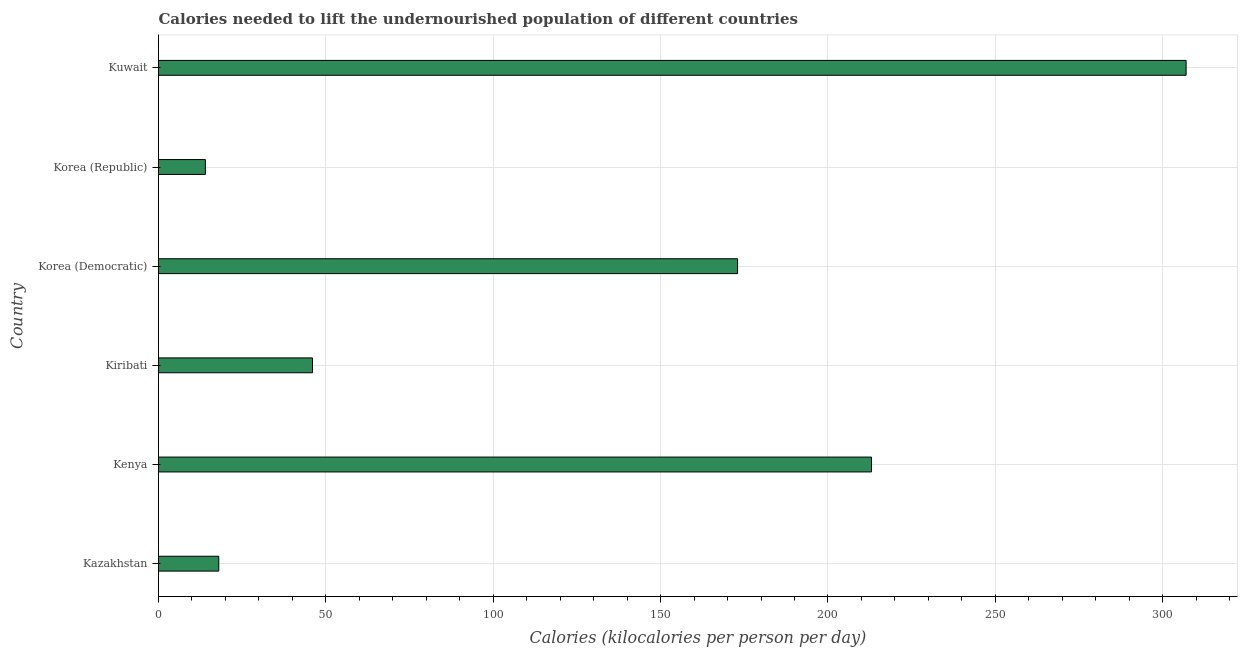Does the graph contain grids?
Your response must be concise. Yes. What is the title of the graph?
Give a very brief answer. Calories needed to lift the undernourished population of different countries. What is the label or title of the X-axis?
Your response must be concise. Calories (kilocalories per person per day). What is the depth of food deficit in Kenya?
Your answer should be compact. 213. Across all countries, what is the maximum depth of food deficit?
Your response must be concise. 307. Across all countries, what is the minimum depth of food deficit?
Provide a short and direct response. 14. In which country was the depth of food deficit maximum?
Offer a very short reply. Kuwait. In which country was the depth of food deficit minimum?
Offer a very short reply. Korea (Republic). What is the sum of the depth of food deficit?
Provide a short and direct response. 771. What is the difference between the depth of food deficit in Kenya and Kiribati?
Provide a succinct answer. 167. What is the average depth of food deficit per country?
Ensure brevity in your answer.  128.5. What is the median depth of food deficit?
Your answer should be very brief. 109.5. In how many countries, is the depth of food deficit greater than 200 kilocalories?
Your answer should be compact. 2. What is the ratio of the depth of food deficit in Korea (Republic) to that in Kuwait?
Your response must be concise. 0.05. Is the depth of food deficit in Kazakhstan less than that in Korea (Democratic)?
Your answer should be compact. Yes. What is the difference between the highest and the second highest depth of food deficit?
Give a very brief answer. 94. Is the sum of the depth of food deficit in Kenya and Korea (Republic) greater than the maximum depth of food deficit across all countries?
Offer a terse response. No. What is the difference between the highest and the lowest depth of food deficit?
Your answer should be very brief. 293. In how many countries, is the depth of food deficit greater than the average depth of food deficit taken over all countries?
Make the answer very short. 3. Are all the bars in the graph horizontal?
Make the answer very short. Yes. What is the Calories (kilocalories per person per day) in Kazakhstan?
Ensure brevity in your answer.  18. What is the Calories (kilocalories per person per day) of Kenya?
Ensure brevity in your answer.  213. What is the Calories (kilocalories per person per day) in Kiribati?
Provide a succinct answer. 46. What is the Calories (kilocalories per person per day) in Korea (Democratic)?
Provide a succinct answer. 173. What is the Calories (kilocalories per person per day) of Kuwait?
Make the answer very short. 307. What is the difference between the Calories (kilocalories per person per day) in Kazakhstan and Kenya?
Give a very brief answer. -195. What is the difference between the Calories (kilocalories per person per day) in Kazakhstan and Kiribati?
Keep it short and to the point. -28. What is the difference between the Calories (kilocalories per person per day) in Kazakhstan and Korea (Democratic)?
Make the answer very short. -155. What is the difference between the Calories (kilocalories per person per day) in Kazakhstan and Korea (Republic)?
Make the answer very short. 4. What is the difference between the Calories (kilocalories per person per day) in Kazakhstan and Kuwait?
Provide a short and direct response. -289. What is the difference between the Calories (kilocalories per person per day) in Kenya and Kiribati?
Your response must be concise. 167. What is the difference between the Calories (kilocalories per person per day) in Kenya and Korea (Democratic)?
Keep it short and to the point. 40. What is the difference between the Calories (kilocalories per person per day) in Kenya and Korea (Republic)?
Offer a very short reply. 199. What is the difference between the Calories (kilocalories per person per day) in Kenya and Kuwait?
Your answer should be very brief. -94. What is the difference between the Calories (kilocalories per person per day) in Kiribati and Korea (Democratic)?
Your answer should be very brief. -127. What is the difference between the Calories (kilocalories per person per day) in Kiribati and Kuwait?
Offer a very short reply. -261. What is the difference between the Calories (kilocalories per person per day) in Korea (Democratic) and Korea (Republic)?
Your response must be concise. 159. What is the difference between the Calories (kilocalories per person per day) in Korea (Democratic) and Kuwait?
Offer a terse response. -134. What is the difference between the Calories (kilocalories per person per day) in Korea (Republic) and Kuwait?
Offer a terse response. -293. What is the ratio of the Calories (kilocalories per person per day) in Kazakhstan to that in Kenya?
Ensure brevity in your answer.  0.09. What is the ratio of the Calories (kilocalories per person per day) in Kazakhstan to that in Kiribati?
Give a very brief answer. 0.39. What is the ratio of the Calories (kilocalories per person per day) in Kazakhstan to that in Korea (Democratic)?
Ensure brevity in your answer.  0.1. What is the ratio of the Calories (kilocalories per person per day) in Kazakhstan to that in Korea (Republic)?
Give a very brief answer. 1.29. What is the ratio of the Calories (kilocalories per person per day) in Kazakhstan to that in Kuwait?
Provide a succinct answer. 0.06. What is the ratio of the Calories (kilocalories per person per day) in Kenya to that in Kiribati?
Give a very brief answer. 4.63. What is the ratio of the Calories (kilocalories per person per day) in Kenya to that in Korea (Democratic)?
Offer a terse response. 1.23. What is the ratio of the Calories (kilocalories per person per day) in Kenya to that in Korea (Republic)?
Offer a very short reply. 15.21. What is the ratio of the Calories (kilocalories per person per day) in Kenya to that in Kuwait?
Keep it short and to the point. 0.69. What is the ratio of the Calories (kilocalories per person per day) in Kiribati to that in Korea (Democratic)?
Provide a succinct answer. 0.27. What is the ratio of the Calories (kilocalories per person per day) in Kiribati to that in Korea (Republic)?
Keep it short and to the point. 3.29. What is the ratio of the Calories (kilocalories per person per day) in Korea (Democratic) to that in Korea (Republic)?
Ensure brevity in your answer.  12.36. What is the ratio of the Calories (kilocalories per person per day) in Korea (Democratic) to that in Kuwait?
Offer a terse response. 0.56. What is the ratio of the Calories (kilocalories per person per day) in Korea (Republic) to that in Kuwait?
Provide a succinct answer. 0.05. 